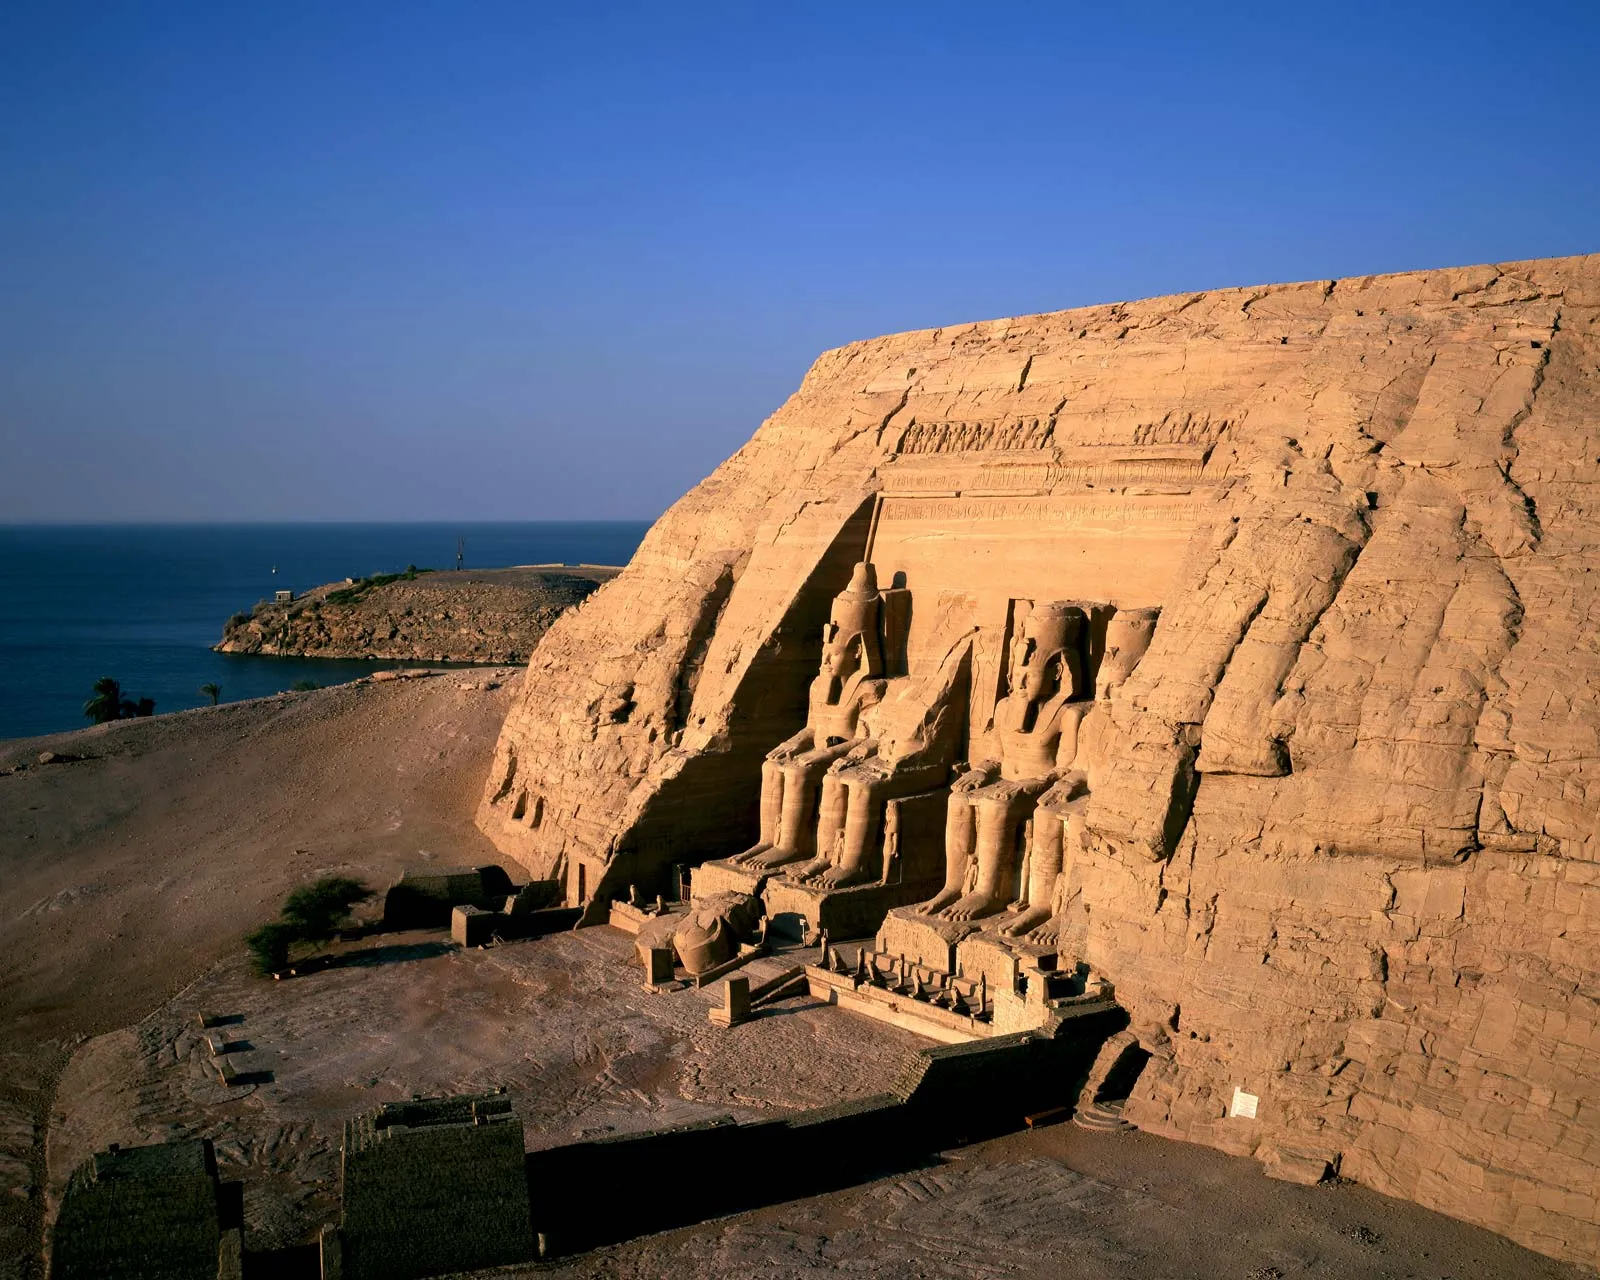Write a detailed description of the given image. The image captures the grandeur of the Abu Simbel temple in Egypt, a remarkable feat of ancient architecture. Carved meticulously into a cliff face, the temple displays four colossal statues of the pharaoh Ramesses II, seated in majestic positions and adorned with the traditional double crown headdress. The statues dominate the scene with an imposing presence, each one showcasing detailed craftsmanship that reflects the significance of the pharaoh in ancient Egyptian society. The camera angle, taken from afar, offers a sweeping view of the temple's entrance, accentuating its monumental scale and the stark beauty of its surroundings. In the background, the serene blue waters of the Nile River contrast beautifully with the arid, sandy tones of the stone, providing a rich context that underlines the temple’s grandeur. The presence of sparse vegetation adds a touch of green, emphasizing the stark environment. This image is a powerful representation of the enduring legacy of ancient Egyptian civilization and its architectural prowess, immortalized in stone against the timeless flow of the Nile. 